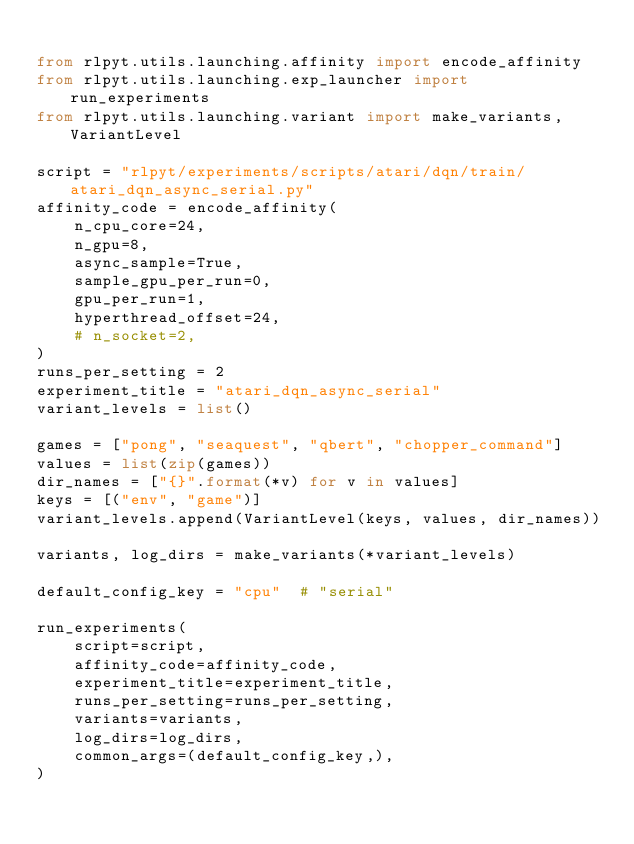Convert code to text. <code><loc_0><loc_0><loc_500><loc_500><_Python_>
from rlpyt.utils.launching.affinity import encode_affinity
from rlpyt.utils.launching.exp_launcher import run_experiments
from rlpyt.utils.launching.variant import make_variants, VariantLevel

script = "rlpyt/experiments/scripts/atari/dqn/train/atari_dqn_async_serial.py"
affinity_code = encode_affinity(
    n_cpu_core=24,
    n_gpu=8,
    async_sample=True,
    sample_gpu_per_run=0,
    gpu_per_run=1,
    hyperthread_offset=24,
    # n_socket=2,
)
runs_per_setting = 2
experiment_title = "atari_dqn_async_serial"
variant_levels = list()

games = ["pong", "seaquest", "qbert", "chopper_command"]
values = list(zip(games))
dir_names = ["{}".format(*v) for v in values]
keys = [("env", "game")]
variant_levels.append(VariantLevel(keys, values, dir_names))

variants, log_dirs = make_variants(*variant_levels)

default_config_key = "cpu"  # "serial"

run_experiments(
    script=script,
    affinity_code=affinity_code,
    experiment_title=experiment_title,
    runs_per_setting=runs_per_setting,
    variants=variants,
    log_dirs=log_dirs,
    common_args=(default_config_key,),
)
</code> 